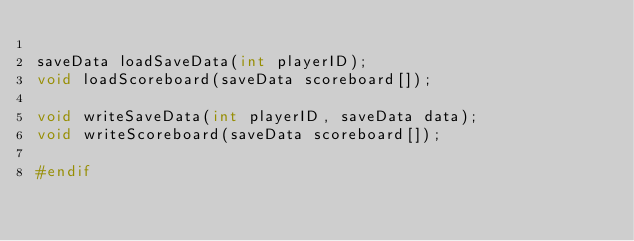<code> <loc_0><loc_0><loc_500><loc_500><_C_>
saveData loadSaveData(int playerID);
void loadScoreboard(saveData scoreboard[]);

void writeSaveData(int playerID, saveData data);
void writeScoreboard(saveData scoreboard[]);

#endif</code> 